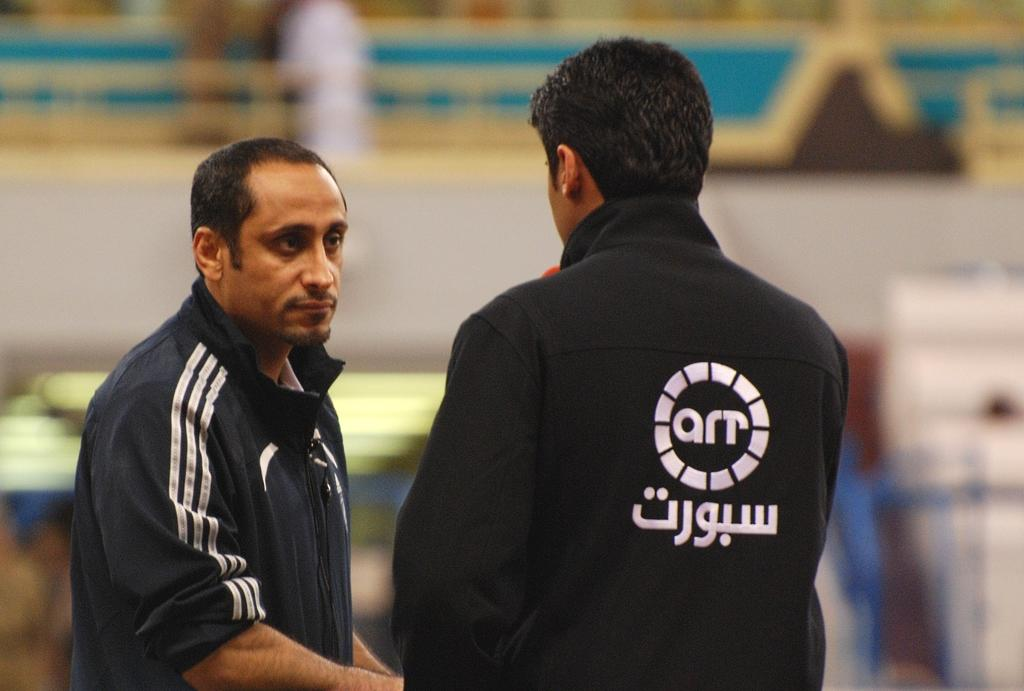<image>
Render a clear and concise summary of the photo. Two men talking, one with foreign language on his shirt. 